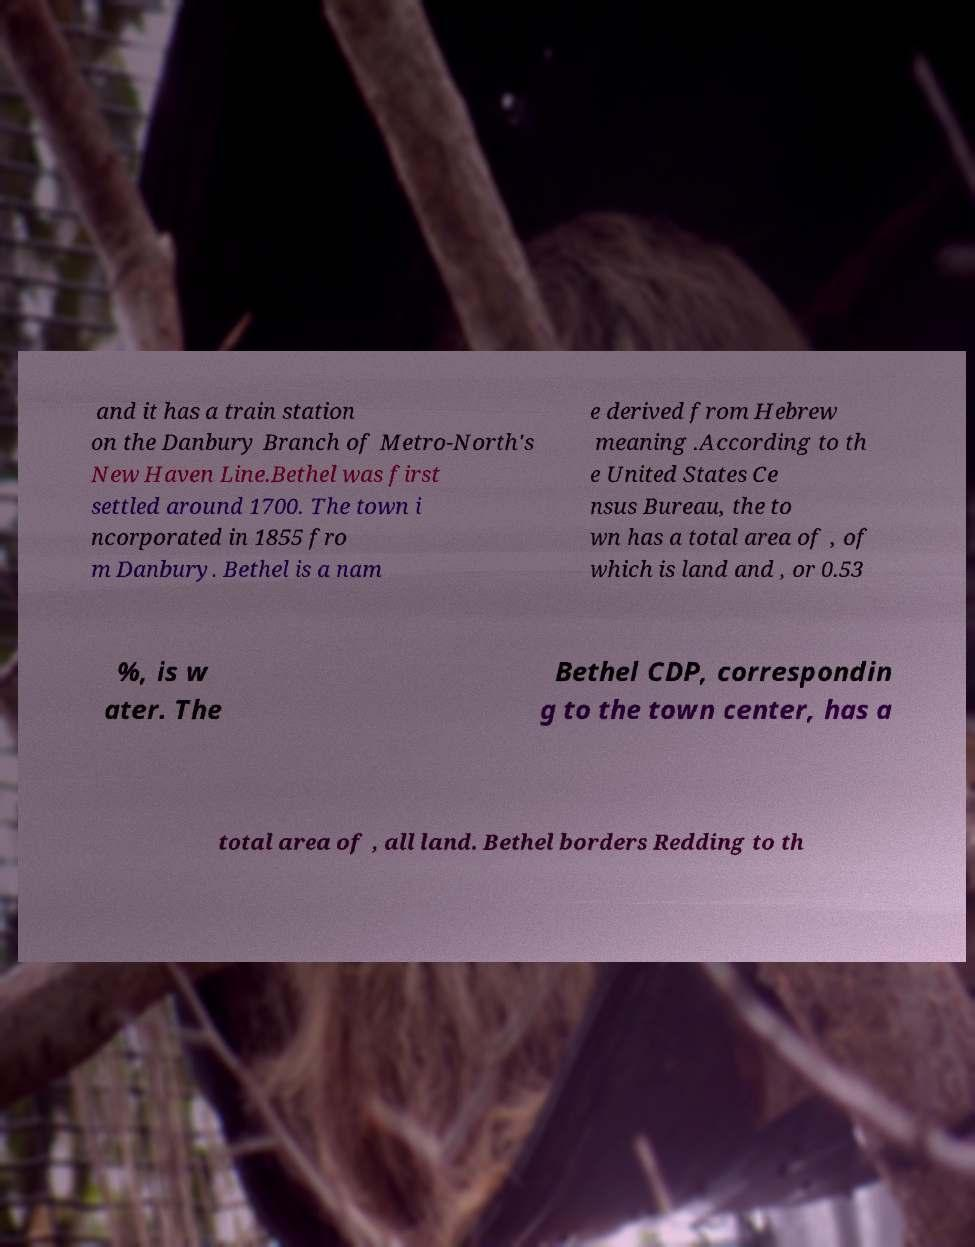Please read and relay the text visible in this image. What does it say? and it has a train station on the Danbury Branch of Metro-North's New Haven Line.Bethel was first settled around 1700. The town i ncorporated in 1855 fro m Danbury. Bethel is a nam e derived from Hebrew meaning .According to th e United States Ce nsus Bureau, the to wn has a total area of , of which is land and , or 0.53 %, is w ater. The Bethel CDP, correspondin g to the town center, has a total area of , all land. Bethel borders Redding to th 